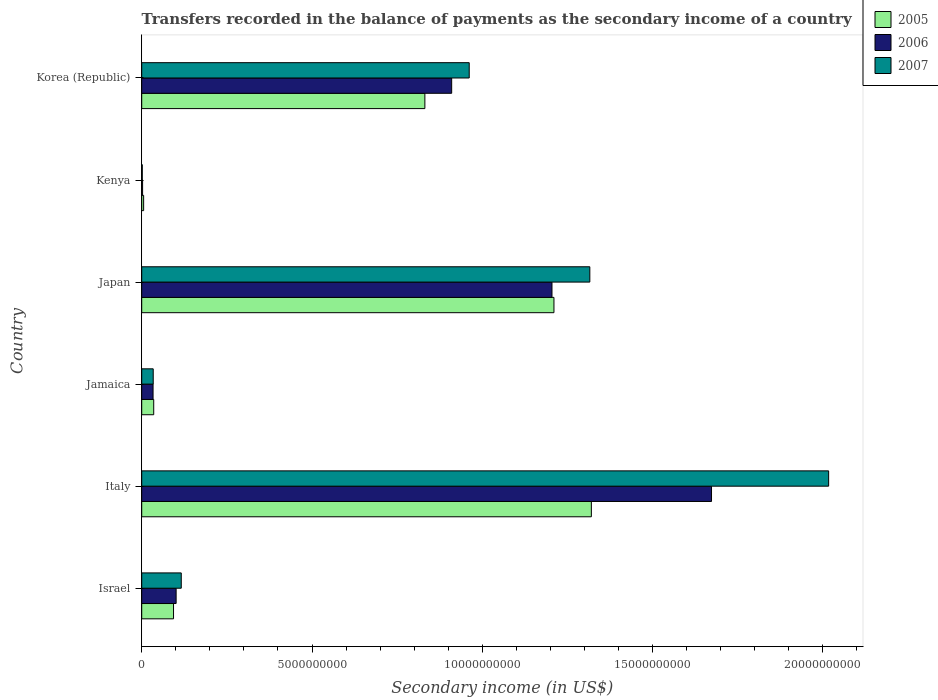Are the number of bars per tick equal to the number of legend labels?
Your answer should be very brief. Yes. What is the label of the 5th group of bars from the top?
Ensure brevity in your answer.  Italy. In how many cases, is the number of bars for a given country not equal to the number of legend labels?
Your answer should be compact. 0. What is the secondary income of in 2007 in Italy?
Provide a succinct answer. 2.02e+1. Across all countries, what is the maximum secondary income of in 2005?
Provide a short and direct response. 1.32e+1. Across all countries, what is the minimum secondary income of in 2007?
Provide a short and direct response. 1.64e+07. In which country was the secondary income of in 2006 minimum?
Give a very brief answer. Kenya. What is the total secondary income of in 2005 in the graph?
Your answer should be very brief. 3.50e+1. What is the difference between the secondary income of in 2007 in Italy and that in Korea (Republic)?
Your response must be concise. 1.06e+1. What is the difference between the secondary income of in 2005 in Japan and the secondary income of in 2007 in Jamaica?
Your answer should be compact. 1.18e+1. What is the average secondary income of in 2007 per country?
Your answer should be very brief. 7.41e+09. What is the difference between the secondary income of in 2005 and secondary income of in 2007 in Kenya?
Your answer should be very brief. 4.00e+07. What is the ratio of the secondary income of in 2006 in Israel to that in Korea (Republic)?
Give a very brief answer. 0.11. Is the secondary income of in 2007 in Israel less than that in Korea (Republic)?
Offer a terse response. Yes. What is the difference between the highest and the second highest secondary income of in 2007?
Ensure brevity in your answer.  7.01e+09. What is the difference between the highest and the lowest secondary income of in 2006?
Keep it short and to the point. 1.67e+1. In how many countries, is the secondary income of in 2007 greater than the average secondary income of in 2007 taken over all countries?
Give a very brief answer. 3. Is the sum of the secondary income of in 2006 in Israel and Kenya greater than the maximum secondary income of in 2005 across all countries?
Your answer should be very brief. No. Is it the case that in every country, the sum of the secondary income of in 2005 and secondary income of in 2007 is greater than the secondary income of in 2006?
Offer a very short reply. Yes. Are all the bars in the graph horizontal?
Make the answer very short. Yes. How many countries are there in the graph?
Your answer should be very brief. 6. What is the difference between two consecutive major ticks on the X-axis?
Your response must be concise. 5.00e+09. Does the graph contain any zero values?
Offer a very short reply. No. Does the graph contain grids?
Ensure brevity in your answer.  No. Where does the legend appear in the graph?
Your answer should be compact. Top right. How many legend labels are there?
Your answer should be very brief. 3. How are the legend labels stacked?
Provide a succinct answer. Vertical. What is the title of the graph?
Provide a succinct answer. Transfers recorded in the balance of payments as the secondary income of a country. What is the label or title of the X-axis?
Your answer should be very brief. Secondary income (in US$). What is the Secondary income (in US$) in 2005 in Israel?
Provide a short and direct response. 9.34e+08. What is the Secondary income (in US$) in 2006 in Israel?
Provide a succinct answer. 1.01e+09. What is the Secondary income (in US$) in 2007 in Israel?
Your answer should be compact. 1.16e+09. What is the Secondary income (in US$) in 2005 in Italy?
Provide a succinct answer. 1.32e+1. What is the Secondary income (in US$) in 2006 in Italy?
Offer a terse response. 1.67e+1. What is the Secondary income (in US$) of 2007 in Italy?
Give a very brief answer. 2.02e+1. What is the Secondary income (in US$) in 2005 in Jamaica?
Your response must be concise. 3.52e+08. What is the Secondary income (in US$) of 2006 in Jamaica?
Offer a very short reply. 3.33e+08. What is the Secondary income (in US$) in 2007 in Jamaica?
Make the answer very short. 3.37e+08. What is the Secondary income (in US$) of 2005 in Japan?
Offer a terse response. 1.21e+1. What is the Secondary income (in US$) of 2006 in Japan?
Your answer should be compact. 1.20e+1. What is the Secondary income (in US$) in 2007 in Japan?
Your answer should be very brief. 1.32e+1. What is the Secondary income (in US$) of 2005 in Kenya?
Offer a very short reply. 5.64e+07. What is the Secondary income (in US$) of 2006 in Kenya?
Ensure brevity in your answer.  2.54e+07. What is the Secondary income (in US$) in 2007 in Kenya?
Keep it short and to the point. 1.64e+07. What is the Secondary income (in US$) of 2005 in Korea (Republic)?
Keep it short and to the point. 8.31e+09. What is the Secondary income (in US$) in 2006 in Korea (Republic)?
Make the answer very short. 9.10e+09. What is the Secondary income (in US$) of 2007 in Korea (Republic)?
Provide a short and direct response. 9.62e+09. Across all countries, what is the maximum Secondary income (in US$) in 2005?
Ensure brevity in your answer.  1.32e+1. Across all countries, what is the maximum Secondary income (in US$) in 2006?
Provide a short and direct response. 1.67e+1. Across all countries, what is the maximum Secondary income (in US$) of 2007?
Give a very brief answer. 2.02e+1. Across all countries, what is the minimum Secondary income (in US$) of 2005?
Make the answer very short. 5.64e+07. Across all countries, what is the minimum Secondary income (in US$) of 2006?
Make the answer very short. 2.54e+07. Across all countries, what is the minimum Secondary income (in US$) of 2007?
Provide a succinct answer. 1.64e+07. What is the total Secondary income (in US$) of 2005 in the graph?
Your answer should be compact. 3.50e+1. What is the total Secondary income (in US$) in 2006 in the graph?
Your answer should be compact. 3.92e+1. What is the total Secondary income (in US$) of 2007 in the graph?
Make the answer very short. 4.45e+1. What is the difference between the Secondary income (in US$) of 2005 in Israel and that in Italy?
Offer a terse response. -1.23e+1. What is the difference between the Secondary income (in US$) of 2006 in Israel and that in Italy?
Provide a succinct answer. -1.57e+1. What is the difference between the Secondary income (in US$) of 2007 in Israel and that in Italy?
Provide a succinct answer. -1.90e+1. What is the difference between the Secondary income (in US$) of 2005 in Israel and that in Jamaica?
Your response must be concise. 5.82e+08. What is the difference between the Secondary income (in US$) of 2006 in Israel and that in Jamaica?
Your answer should be compact. 6.77e+08. What is the difference between the Secondary income (in US$) in 2007 in Israel and that in Jamaica?
Your answer should be very brief. 8.24e+08. What is the difference between the Secondary income (in US$) of 2005 in Israel and that in Japan?
Your answer should be very brief. -1.12e+1. What is the difference between the Secondary income (in US$) of 2006 in Israel and that in Japan?
Ensure brevity in your answer.  -1.10e+1. What is the difference between the Secondary income (in US$) of 2007 in Israel and that in Japan?
Give a very brief answer. -1.20e+1. What is the difference between the Secondary income (in US$) in 2005 in Israel and that in Kenya?
Your response must be concise. 8.78e+08. What is the difference between the Secondary income (in US$) of 2006 in Israel and that in Kenya?
Give a very brief answer. 9.85e+08. What is the difference between the Secondary income (in US$) in 2007 in Israel and that in Kenya?
Offer a very short reply. 1.14e+09. What is the difference between the Secondary income (in US$) of 2005 in Israel and that in Korea (Republic)?
Give a very brief answer. -7.38e+09. What is the difference between the Secondary income (in US$) of 2006 in Israel and that in Korea (Republic)?
Provide a short and direct response. -8.09e+09. What is the difference between the Secondary income (in US$) of 2007 in Israel and that in Korea (Republic)?
Provide a succinct answer. -8.45e+09. What is the difference between the Secondary income (in US$) in 2005 in Italy and that in Jamaica?
Offer a terse response. 1.28e+1. What is the difference between the Secondary income (in US$) of 2006 in Italy and that in Jamaica?
Your answer should be compact. 1.64e+1. What is the difference between the Secondary income (in US$) of 2007 in Italy and that in Jamaica?
Offer a very short reply. 1.98e+1. What is the difference between the Secondary income (in US$) in 2005 in Italy and that in Japan?
Your answer should be compact. 1.10e+09. What is the difference between the Secondary income (in US$) of 2006 in Italy and that in Japan?
Your answer should be very brief. 4.68e+09. What is the difference between the Secondary income (in US$) of 2007 in Italy and that in Japan?
Your response must be concise. 7.01e+09. What is the difference between the Secondary income (in US$) of 2005 in Italy and that in Kenya?
Provide a succinct answer. 1.31e+1. What is the difference between the Secondary income (in US$) in 2006 in Italy and that in Kenya?
Your answer should be very brief. 1.67e+1. What is the difference between the Secondary income (in US$) of 2007 in Italy and that in Kenya?
Ensure brevity in your answer.  2.02e+1. What is the difference between the Secondary income (in US$) in 2005 in Italy and that in Korea (Republic)?
Offer a terse response. 4.89e+09. What is the difference between the Secondary income (in US$) in 2006 in Italy and that in Korea (Republic)?
Provide a short and direct response. 7.63e+09. What is the difference between the Secondary income (in US$) in 2007 in Italy and that in Korea (Republic)?
Make the answer very short. 1.06e+1. What is the difference between the Secondary income (in US$) in 2005 in Jamaica and that in Japan?
Make the answer very short. -1.18e+1. What is the difference between the Secondary income (in US$) in 2006 in Jamaica and that in Japan?
Make the answer very short. -1.17e+1. What is the difference between the Secondary income (in US$) of 2007 in Jamaica and that in Japan?
Give a very brief answer. -1.28e+1. What is the difference between the Secondary income (in US$) in 2005 in Jamaica and that in Kenya?
Make the answer very short. 2.96e+08. What is the difference between the Secondary income (in US$) of 2006 in Jamaica and that in Kenya?
Your response must be concise. 3.08e+08. What is the difference between the Secondary income (in US$) in 2007 in Jamaica and that in Kenya?
Your answer should be compact. 3.21e+08. What is the difference between the Secondary income (in US$) of 2005 in Jamaica and that in Korea (Republic)?
Provide a succinct answer. -7.96e+09. What is the difference between the Secondary income (in US$) in 2006 in Jamaica and that in Korea (Republic)?
Offer a very short reply. -8.77e+09. What is the difference between the Secondary income (in US$) of 2007 in Jamaica and that in Korea (Republic)?
Provide a short and direct response. -9.28e+09. What is the difference between the Secondary income (in US$) of 2005 in Japan and that in Kenya?
Offer a terse response. 1.20e+1. What is the difference between the Secondary income (in US$) in 2006 in Japan and that in Kenya?
Offer a very short reply. 1.20e+1. What is the difference between the Secondary income (in US$) of 2007 in Japan and that in Kenya?
Your answer should be compact. 1.31e+1. What is the difference between the Secondary income (in US$) of 2005 in Japan and that in Korea (Republic)?
Keep it short and to the point. 3.79e+09. What is the difference between the Secondary income (in US$) of 2006 in Japan and that in Korea (Republic)?
Make the answer very short. 2.95e+09. What is the difference between the Secondary income (in US$) in 2007 in Japan and that in Korea (Republic)?
Your response must be concise. 3.54e+09. What is the difference between the Secondary income (in US$) of 2005 in Kenya and that in Korea (Republic)?
Offer a very short reply. -8.26e+09. What is the difference between the Secondary income (in US$) of 2006 in Kenya and that in Korea (Republic)?
Your answer should be compact. -9.08e+09. What is the difference between the Secondary income (in US$) in 2007 in Kenya and that in Korea (Republic)?
Provide a succinct answer. -9.60e+09. What is the difference between the Secondary income (in US$) in 2005 in Israel and the Secondary income (in US$) in 2006 in Italy?
Give a very brief answer. -1.58e+1. What is the difference between the Secondary income (in US$) of 2005 in Israel and the Secondary income (in US$) of 2007 in Italy?
Make the answer very short. -1.92e+1. What is the difference between the Secondary income (in US$) in 2006 in Israel and the Secondary income (in US$) in 2007 in Italy?
Offer a very short reply. -1.92e+1. What is the difference between the Secondary income (in US$) in 2005 in Israel and the Secondary income (in US$) in 2006 in Jamaica?
Your answer should be very brief. 6.01e+08. What is the difference between the Secondary income (in US$) of 2005 in Israel and the Secondary income (in US$) of 2007 in Jamaica?
Give a very brief answer. 5.97e+08. What is the difference between the Secondary income (in US$) in 2006 in Israel and the Secondary income (in US$) in 2007 in Jamaica?
Offer a very short reply. 6.73e+08. What is the difference between the Secondary income (in US$) of 2005 in Israel and the Secondary income (in US$) of 2006 in Japan?
Provide a short and direct response. -1.11e+1. What is the difference between the Secondary income (in US$) of 2005 in Israel and the Secondary income (in US$) of 2007 in Japan?
Ensure brevity in your answer.  -1.22e+1. What is the difference between the Secondary income (in US$) of 2006 in Israel and the Secondary income (in US$) of 2007 in Japan?
Offer a terse response. -1.21e+1. What is the difference between the Secondary income (in US$) in 2005 in Israel and the Secondary income (in US$) in 2006 in Kenya?
Provide a short and direct response. 9.09e+08. What is the difference between the Secondary income (in US$) in 2005 in Israel and the Secondary income (in US$) in 2007 in Kenya?
Give a very brief answer. 9.18e+08. What is the difference between the Secondary income (in US$) in 2006 in Israel and the Secondary income (in US$) in 2007 in Kenya?
Offer a very short reply. 9.94e+08. What is the difference between the Secondary income (in US$) in 2005 in Israel and the Secondary income (in US$) in 2006 in Korea (Republic)?
Provide a succinct answer. -8.17e+09. What is the difference between the Secondary income (in US$) in 2005 in Israel and the Secondary income (in US$) in 2007 in Korea (Republic)?
Your answer should be compact. -8.68e+09. What is the difference between the Secondary income (in US$) in 2006 in Israel and the Secondary income (in US$) in 2007 in Korea (Republic)?
Keep it short and to the point. -8.61e+09. What is the difference between the Secondary income (in US$) of 2005 in Italy and the Secondary income (in US$) of 2006 in Jamaica?
Your answer should be compact. 1.29e+1. What is the difference between the Secondary income (in US$) of 2005 in Italy and the Secondary income (in US$) of 2007 in Jamaica?
Your response must be concise. 1.29e+1. What is the difference between the Secondary income (in US$) of 2006 in Italy and the Secondary income (in US$) of 2007 in Jamaica?
Provide a succinct answer. 1.64e+1. What is the difference between the Secondary income (in US$) of 2005 in Italy and the Secondary income (in US$) of 2006 in Japan?
Offer a terse response. 1.16e+09. What is the difference between the Secondary income (in US$) in 2005 in Italy and the Secondary income (in US$) in 2007 in Japan?
Provide a succinct answer. 4.48e+07. What is the difference between the Secondary income (in US$) in 2006 in Italy and the Secondary income (in US$) in 2007 in Japan?
Provide a succinct answer. 3.57e+09. What is the difference between the Secondary income (in US$) in 2005 in Italy and the Secondary income (in US$) in 2006 in Kenya?
Keep it short and to the point. 1.32e+1. What is the difference between the Secondary income (in US$) in 2005 in Italy and the Secondary income (in US$) in 2007 in Kenya?
Give a very brief answer. 1.32e+1. What is the difference between the Secondary income (in US$) in 2006 in Italy and the Secondary income (in US$) in 2007 in Kenya?
Your answer should be compact. 1.67e+1. What is the difference between the Secondary income (in US$) of 2005 in Italy and the Secondary income (in US$) of 2006 in Korea (Republic)?
Provide a succinct answer. 4.10e+09. What is the difference between the Secondary income (in US$) in 2005 in Italy and the Secondary income (in US$) in 2007 in Korea (Republic)?
Offer a very short reply. 3.59e+09. What is the difference between the Secondary income (in US$) in 2006 in Italy and the Secondary income (in US$) in 2007 in Korea (Republic)?
Your answer should be very brief. 7.11e+09. What is the difference between the Secondary income (in US$) in 2005 in Jamaica and the Secondary income (in US$) in 2006 in Japan?
Your answer should be very brief. -1.17e+1. What is the difference between the Secondary income (in US$) in 2005 in Jamaica and the Secondary income (in US$) in 2007 in Japan?
Offer a terse response. -1.28e+1. What is the difference between the Secondary income (in US$) of 2006 in Jamaica and the Secondary income (in US$) of 2007 in Japan?
Your answer should be very brief. -1.28e+1. What is the difference between the Secondary income (in US$) of 2005 in Jamaica and the Secondary income (in US$) of 2006 in Kenya?
Ensure brevity in your answer.  3.27e+08. What is the difference between the Secondary income (in US$) of 2005 in Jamaica and the Secondary income (in US$) of 2007 in Kenya?
Your response must be concise. 3.36e+08. What is the difference between the Secondary income (in US$) in 2006 in Jamaica and the Secondary income (in US$) in 2007 in Kenya?
Provide a short and direct response. 3.17e+08. What is the difference between the Secondary income (in US$) of 2005 in Jamaica and the Secondary income (in US$) of 2006 in Korea (Republic)?
Your response must be concise. -8.75e+09. What is the difference between the Secondary income (in US$) of 2005 in Jamaica and the Secondary income (in US$) of 2007 in Korea (Republic)?
Make the answer very short. -9.26e+09. What is the difference between the Secondary income (in US$) of 2006 in Jamaica and the Secondary income (in US$) of 2007 in Korea (Republic)?
Provide a short and direct response. -9.28e+09. What is the difference between the Secondary income (in US$) in 2005 in Japan and the Secondary income (in US$) in 2006 in Kenya?
Give a very brief answer. 1.21e+1. What is the difference between the Secondary income (in US$) of 2005 in Japan and the Secondary income (in US$) of 2007 in Kenya?
Keep it short and to the point. 1.21e+1. What is the difference between the Secondary income (in US$) in 2006 in Japan and the Secondary income (in US$) in 2007 in Kenya?
Your answer should be compact. 1.20e+1. What is the difference between the Secondary income (in US$) of 2005 in Japan and the Secondary income (in US$) of 2006 in Korea (Republic)?
Your answer should be very brief. 3.00e+09. What is the difference between the Secondary income (in US$) of 2005 in Japan and the Secondary income (in US$) of 2007 in Korea (Republic)?
Your response must be concise. 2.49e+09. What is the difference between the Secondary income (in US$) of 2006 in Japan and the Secondary income (in US$) of 2007 in Korea (Republic)?
Give a very brief answer. 2.43e+09. What is the difference between the Secondary income (in US$) of 2005 in Kenya and the Secondary income (in US$) of 2006 in Korea (Republic)?
Offer a terse response. -9.04e+09. What is the difference between the Secondary income (in US$) of 2005 in Kenya and the Secondary income (in US$) of 2007 in Korea (Republic)?
Ensure brevity in your answer.  -9.56e+09. What is the difference between the Secondary income (in US$) in 2006 in Kenya and the Secondary income (in US$) in 2007 in Korea (Republic)?
Provide a short and direct response. -9.59e+09. What is the average Secondary income (in US$) in 2005 per country?
Give a very brief answer. 5.83e+09. What is the average Secondary income (in US$) in 2006 per country?
Offer a terse response. 6.54e+09. What is the average Secondary income (in US$) in 2007 per country?
Keep it short and to the point. 7.41e+09. What is the difference between the Secondary income (in US$) in 2005 and Secondary income (in US$) in 2006 in Israel?
Your answer should be very brief. -7.63e+07. What is the difference between the Secondary income (in US$) of 2005 and Secondary income (in US$) of 2007 in Israel?
Make the answer very short. -2.27e+08. What is the difference between the Secondary income (in US$) of 2006 and Secondary income (in US$) of 2007 in Israel?
Provide a short and direct response. -1.51e+08. What is the difference between the Secondary income (in US$) of 2005 and Secondary income (in US$) of 2006 in Italy?
Make the answer very short. -3.53e+09. What is the difference between the Secondary income (in US$) of 2005 and Secondary income (in US$) of 2007 in Italy?
Your answer should be very brief. -6.97e+09. What is the difference between the Secondary income (in US$) of 2006 and Secondary income (in US$) of 2007 in Italy?
Provide a short and direct response. -3.44e+09. What is the difference between the Secondary income (in US$) of 2005 and Secondary income (in US$) of 2006 in Jamaica?
Offer a very short reply. 1.90e+07. What is the difference between the Secondary income (in US$) in 2005 and Secondary income (in US$) in 2007 in Jamaica?
Give a very brief answer. 1.47e+07. What is the difference between the Secondary income (in US$) in 2006 and Secondary income (in US$) in 2007 in Jamaica?
Offer a very short reply. -4.31e+06. What is the difference between the Secondary income (in US$) in 2005 and Secondary income (in US$) in 2006 in Japan?
Keep it short and to the point. 5.76e+07. What is the difference between the Secondary income (in US$) in 2005 and Secondary income (in US$) in 2007 in Japan?
Your answer should be compact. -1.05e+09. What is the difference between the Secondary income (in US$) in 2006 and Secondary income (in US$) in 2007 in Japan?
Keep it short and to the point. -1.11e+09. What is the difference between the Secondary income (in US$) of 2005 and Secondary income (in US$) of 2006 in Kenya?
Provide a short and direct response. 3.10e+07. What is the difference between the Secondary income (in US$) in 2005 and Secondary income (in US$) in 2007 in Kenya?
Give a very brief answer. 4.00e+07. What is the difference between the Secondary income (in US$) of 2006 and Secondary income (in US$) of 2007 in Kenya?
Offer a very short reply. 9.03e+06. What is the difference between the Secondary income (in US$) of 2005 and Secondary income (in US$) of 2006 in Korea (Republic)?
Your response must be concise. -7.86e+08. What is the difference between the Secondary income (in US$) in 2005 and Secondary income (in US$) in 2007 in Korea (Republic)?
Provide a short and direct response. -1.30e+09. What is the difference between the Secondary income (in US$) of 2006 and Secondary income (in US$) of 2007 in Korea (Republic)?
Ensure brevity in your answer.  -5.15e+08. What is the ratio of the Secondary income (in US$) of 2005 in Israel to that in Italy?
Your answer should be very brief. 0.07. What is the ratio of the Secondary income (in US$) in 2006 in Israel to that in Italy?
Your answer should be very brief. 0.06. What is the ratio of the Secondary income (in US$) in 2007 in Israel to that in Italy?
Provide a succinct answer. 0.06. What is the ratio of the Secondary income (in US$) of 2005 in Israel to that in Jamaica?
Make the answer very short. 2.65. What is the ratio of the Secondary income (in US$) in 2006 in Israel to that in Jamaica?
Your answer should be very brief. 3.03. What is the ratio of the Secondary income (in US$) of 2007 in Israel to that in Jamaica?
Make the answer very short. 3.44. What is the ratio of the Secondary income (in US$) in 2005 in Israel to that in Japan?
Your response must be concise. 0.08. What is the ratio of the Secondary income (in US$) in 2006 in Israel to that in Japan?
Your answer should be very brief. 0.08. What is the ratio of the Secondary income (in US$) in 2007 in Israel to that in Japan?
Provide a succinct answer. 0.09. What is the ratio of the Secondary income (in US$) in 2005 in Israel to that in Kenya?
Give a very brief answer. 16.56. What is the ratio of the Secondary income (in US$) of 2006 in Israel to that in Kenya?
Keep it short and to the point. 39.78. What is the ratio of the Secondary income (in US$) in 2007 in Israel to that in Kenya?
Keep it short and to the point. 70.95. What is the ratio of the Secondary income (in US$) in 2005 in Israel to that in Korea (Republic)?
Offer a very short reply. 0.11. What is the ratio of the Secondary income (in US$) of 2006 in Israel to that in Korea (Republic)?
Your response must be concise. 0.11. What is the ratio of the Secondary income (in US$) in 2007 in Israel to that in Korea (Republic)?
Ensure brevity in your answer.  0.12. What is the ratio of the Secondary income (in US$) in 2005 in Italy to that in Jamaica?
Your answer should be very brief. 37.48. What is the ratio of the Secondary income (in US$) of 2006 in Italy to that in Jamaica?
Provide a short and direct response. 50.21. What is the ratio of the Secondary income (in US$) of 2007 in Italy to that in Jamaica?
Offer a very short reply. 59.76. What is the ratio of the Secondary income (in US$) in 2005 in Italy to that in Japan?
Provide a short and direct response. 1.09. What is the ratio of the Secondary income (in US$) in 2006 in Italy to that in Japan?
Make the answer very short. 1.39. What is the ratio of the Secondary income (in US$) of 2007 in Italy to that in Japan?
Give a very brief answer. 1.53. What is the ratio of the Secondary income (in US$) in 2005 in Italy to that in Kenya?
Provide a short and direct response. 234.04. What is the ratio of the Secondary income (in US$) in 2006 in Italy to that in Kenya?
Your answer should be compact. 658.68. What is the ratio of the Secondary income (in US$) of 2007 in Italy to that in Kenya?
Provide a short and direct response. 1232.49. What is the ratio of the Secondary income (in US$) in 2005 in Italy to that in Korea (Republic)?
Your response must be concise. 1.59. What is the ratio of the Secondary income (in US$) in 2006 in Italy to that in Korea (Republic)?
Your answer should be very brief. 1.84. What is the ratio of the Secondary income (in US$) of 2007 in Italy to that in Korea (Republic)?
Keep it short and to the point. 2.1. What is the ratio of the Secondary income (in US$) of 2005 in Jamaica to that in Japan?
Ensure brevity in your answer.  0.03. What is the ratio of the Secondary income (in US$) of 2006 in Jamaica to that in Japan?
Keep it short and to the point. 0.03. What is the ratio of the Secondary income (in US$) of 2007 in Jamaica to that in Japan?
Your answer should be compact. 0.03. What is the ratio of the Secondary income (in US$) of 2005 in Jamaica to that in Kenya?
Provide a succinct answer. 6.24. What is the ratio of the Secondary income (in US$) in 2006 in Jamaica to that in Kenya?
Provide a succinct answer. 13.12. What is the ratio of the Secondary income (in US$) in 2007 in Jamaica to that in Kenya?
Provide a short and direct response. 20.62. What is the ratio of the Secondary income (in US$) in 2005 in Jamaica to that in Korea (Republic)?
Provide a short and direct response. 0.04. What is the ratio of the Secondary income (in US$) of 2006 in Jamaica to that in Korea (Republic)?
Make the answer very short. 0.04. What is the ratio of the Secondary income (in US$) of 2007 in Jamaica to that in Korea (Republic)?
Offer a terse response. 0.04. What is the ratio of the Secondary income (in US$) of 2005 in Japan to that in Kenya?
Give a very brief answer. 214.57. What is the ratio of the Secondary income (in US$) of 2006 in Japan to that in Kenya?
Your answer should be compact. 474.27. What is the ratio of the Secondary income (in US$) of 2007 in Japan to that in Kenya?
Your answer should be very brief. 804. What is the ratio of the Secondary income (in US$) of 2005 in Japan to that in Korea (Republic)?
Offer a terse response. 1.46. What is the ratio of the Secondary income (in US$) in 2006 in Japan to that in Korea (Republic)?
Provide a short and direct response. 1.32. What is the ratio of the Secondary income (in US$) in 2007 in Japan to that in Korea (Republic)?
Keep it short and to the point. 1.37. What is the ratio of the Secondary income (in US$) in 2005 in Kenya to that in Korea (Republic)?
Make the answer very short. 0.01. What is the ratio of the Secondary income (in US$) of 2006 in Kenya to that in Korea (Republic)?
Keep it short and to the point. 0. What is the ratio of the Secondary income (in US$) of 2007 in Kenya to that in Korea (Republic)?
Your answer should be very brief. 0. What is the difference between the highest and the second highest Secondary income (in US$) of 2005?
Offer a terse response. 1.10e+09. What is the difference between the highest and the second highest Secondary income (in US$) of 2006?
Your response must be concise. 4.68e+09. What is the difference between the highest and the second highest Secondary income (in US$) of 2007?
Your response must be concise. 7.01e+09. What is the difference between the highest and the lowest Secondary income (in US$) of 2005?
Your answer should be very brief. 1.31e+1. What is the difference between the highest and the lowest Secondary income (in US$) in 2006?
Keep it short and to the point. 1.67e+1. What is the difference between the highest and the lowest Secondary income (in US$) of 2007?
Your answer should be compact. 2.02e+1. 